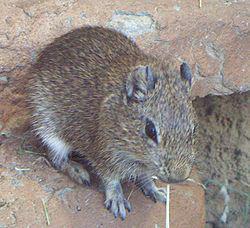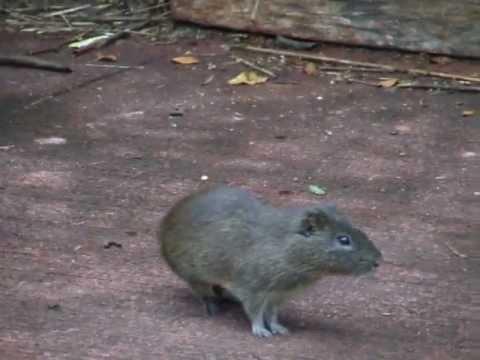The first image is the image on the left, the second image is the image on the right. Considering the images on both sides, is "There are two guinea pigs on the ground in the image on the right." valid? Answer yes or no. No. 